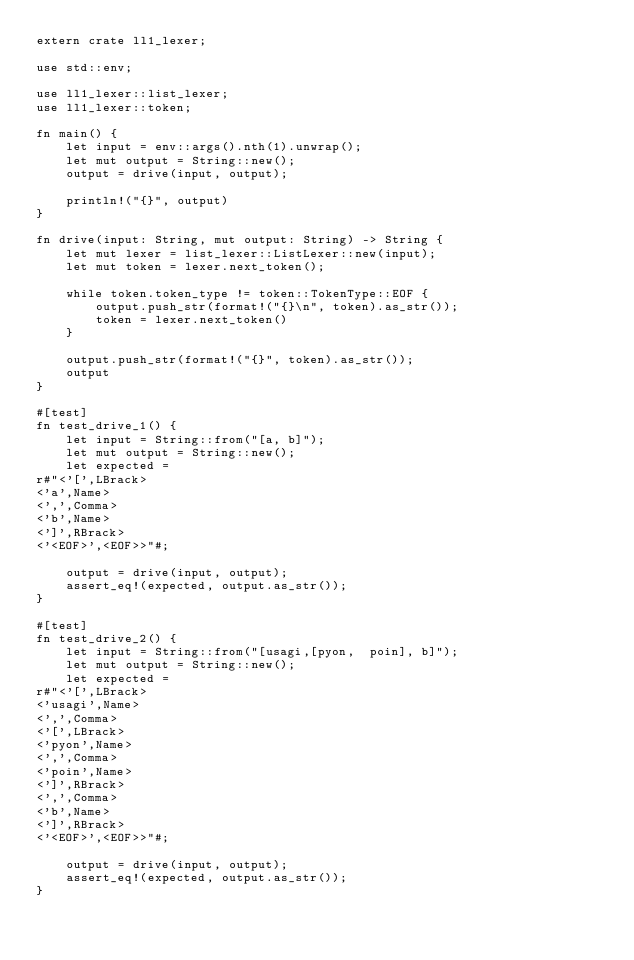<code> <loc_0><loc_0><loc_500><loc_500><_Rust_>extern crate ll1_lexer;

use std::env;

use ll1_lexer::list_lexer;
use ll1_lexer::token;

fn main() {
    let input = env::args().nth(1).unwrap();
    let mut output = String::new();
    output = drive(input, output);

    println!("{}", output)
}

fn drive(input: String, mut output: String) -> String {
    let mut lexer = list_lexer::ListLexer::new(input);
    let mut token = lexer.next_token();

    while token.token_type != token::TokenType::EOF {
        output.push_str(format!("{}\n", token).as_str());
        token = lexer.next_token()
    }

    output.push_str(format!("{}", token).as_str());
    output
}

#[test]
fn test_drive_1() {
    let input = String::from("[a, b]");
    let mut output = String::new();
    let expected =
r#"<'[',LBrack>
<'a',Name>
<',',Comma>
<'b',Name>
<']',RBrack>
<'<EOF>',<EOF>>"#;

    output = drive(input, output);
    assert_eq!(expected, output.as_str());
}

#[test]
fn test_drive_2() {
    let input = String::from("[usagi,[pyon,  poin], b]");
    let mut output = String::new();
    let expected =
r#"<'[',LBrack>
<'usagi',Name>
<',',Comma>
<'[',LBrack>
<'pyon',Name>
<',',Comma>
<'poin',Name>
<']',RBrack>
<',',Comma>
<'b',Name>
<']',RBrack>
<'<EOF>',<EOF>>"#;

    output = drive(input, output);
    assert_eq!(expected, output.as_str());
}
</code> 